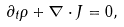Convert formula to latex. <formula><loc_0><loc_0><loc_500><loc_500>\partial _ { t } \rho + \nabla \cdot J = 0 ,</formula> 